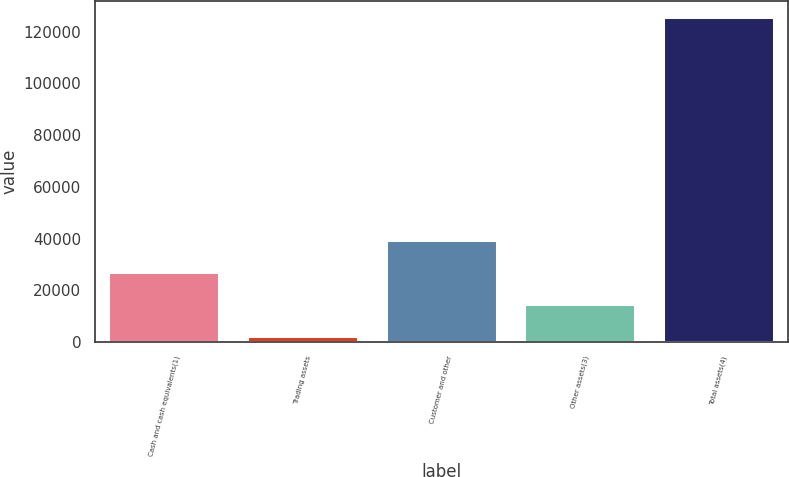<chart> <loc_0><loc_0><loc_500><loc_500><bar_chart><fcel>Cash and cash equivalents(1)<fcel>Trading assets<fcel>Customer and other<fcel>Other assets(3)<fcel>Total assets(4)<nl><fcel>26941<fcel>2285<fcel>39269<fcel>14613<fcel>125565<nl></chart> 